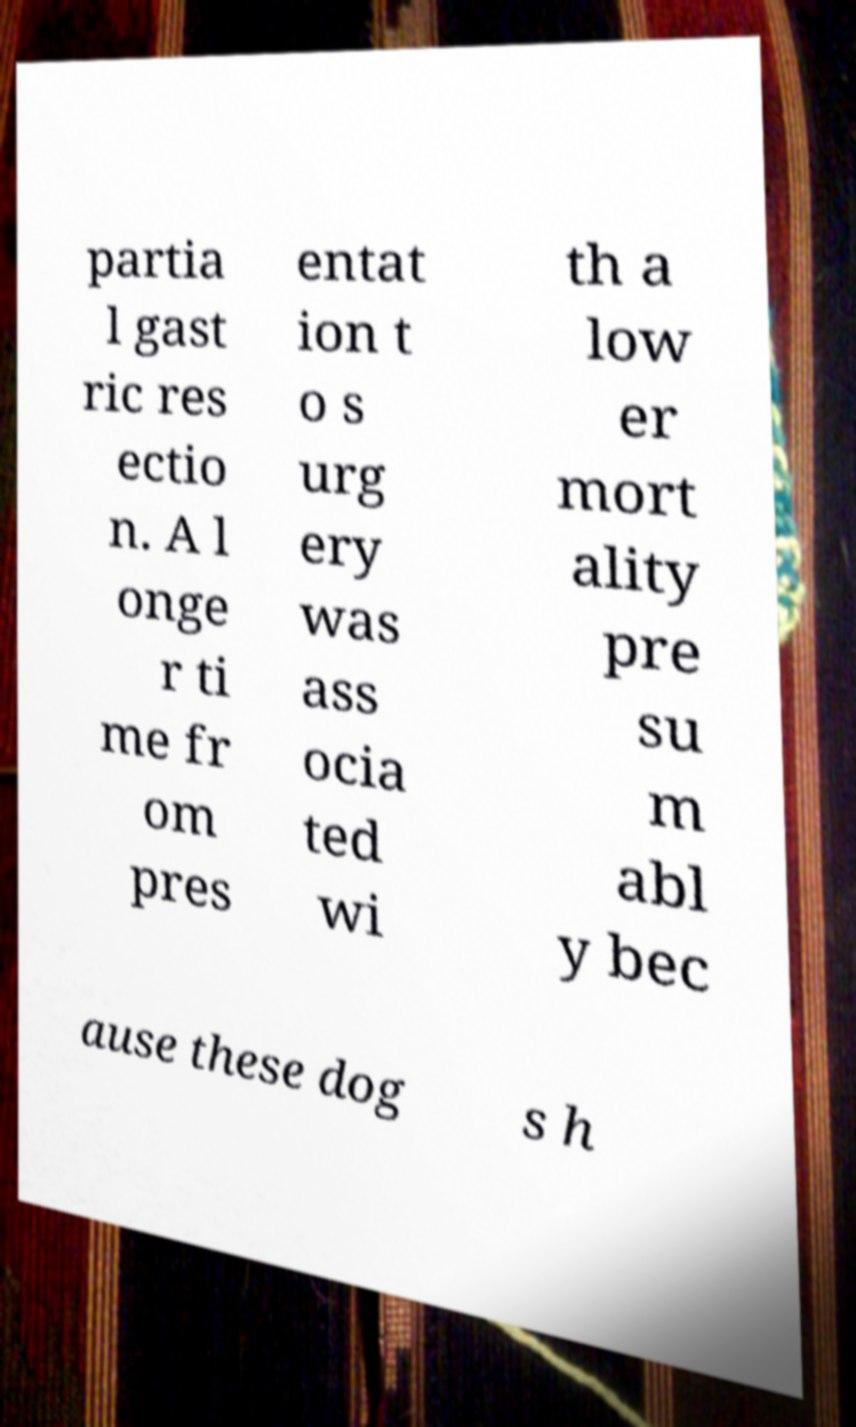Can you accurately transcribe the text from the provided image for me? partia l gast ric res ectio n. A l onge r ti me fr om pres entat ion t o s urg ery was ass ocia ted wi th a low er mort ality pre su m abl y bec ause these dog s h 